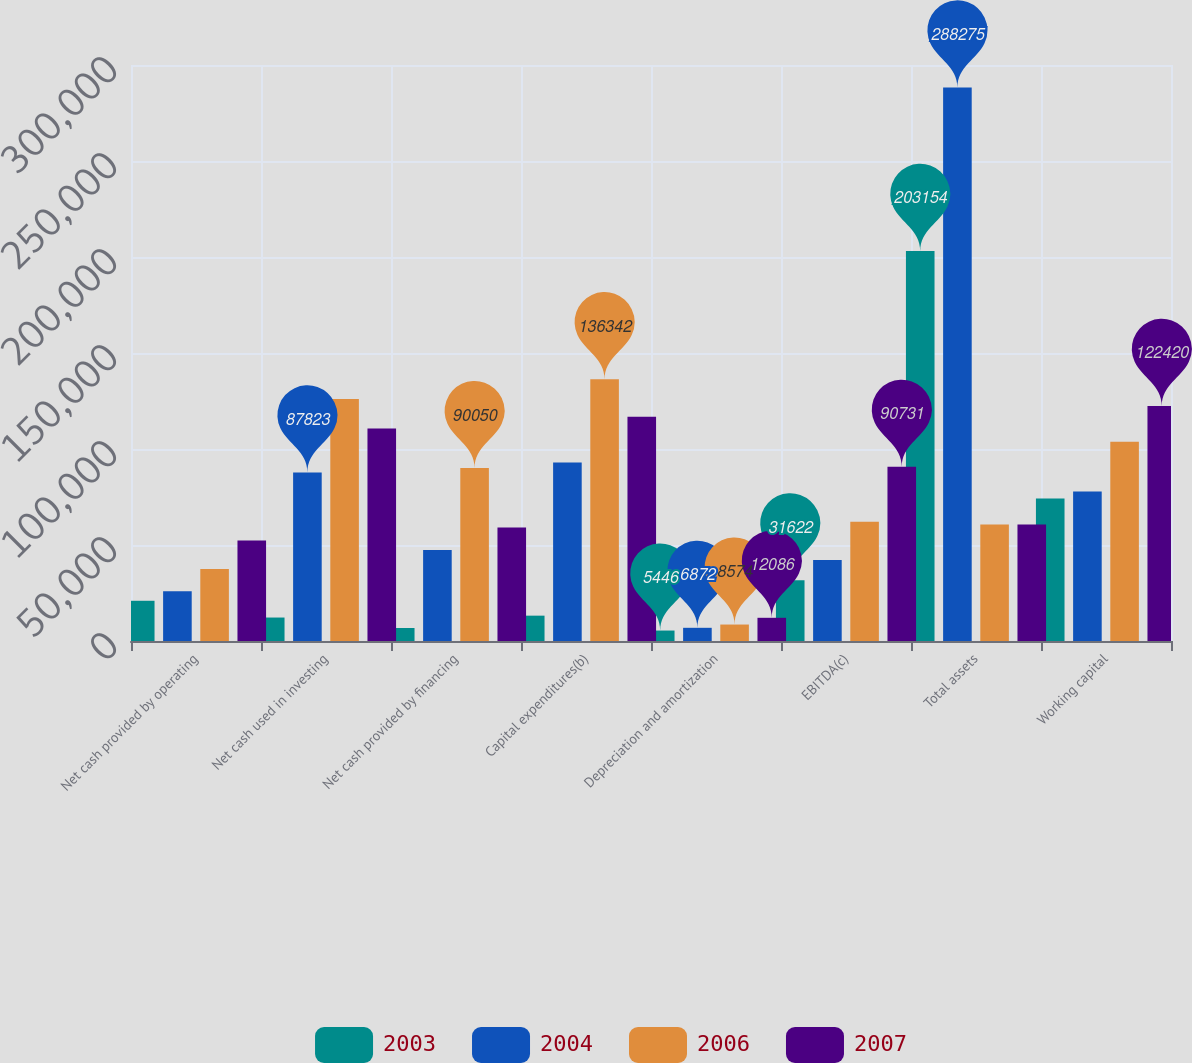<chart> <loc_0><loc_0><loc_500><loc_500><stacked_bar_chart><ecel><fcel>Net cash provided by operating<fcel>Net cash used in investing<fcel>Net cash provided by financing<fcel>Capital expenditures(b)<fcel>Depreciation and amortization<fcel>EBITDA(c)<fcel>Total assets<fcel>Working capital<nl><fcel>2003<fcel>20949<fcel>12222<fcel>6770<fcel>13200<fcel>5446<fcel>31622<fcel>203154<fcel>74184<nl><fcel>2004<fcel>25901<fcel>87823<fcel>47452<fcel>93025<fcel>6872<fcel>42234<fcel>288275<fcel>77879<nl><fcel>2006<fcel>37533<fcel>126022<fcel>90050<fcel>136342<fcel>8574<fcel>62144<fcel>60639<fcel>103776<nl><fcel>2007<fcel>52381<fcel>110657<fcel>59134<fcel>116844<fcel>12086<fcel>90731<fcel>60639<fcel>122420<nl></chart> 